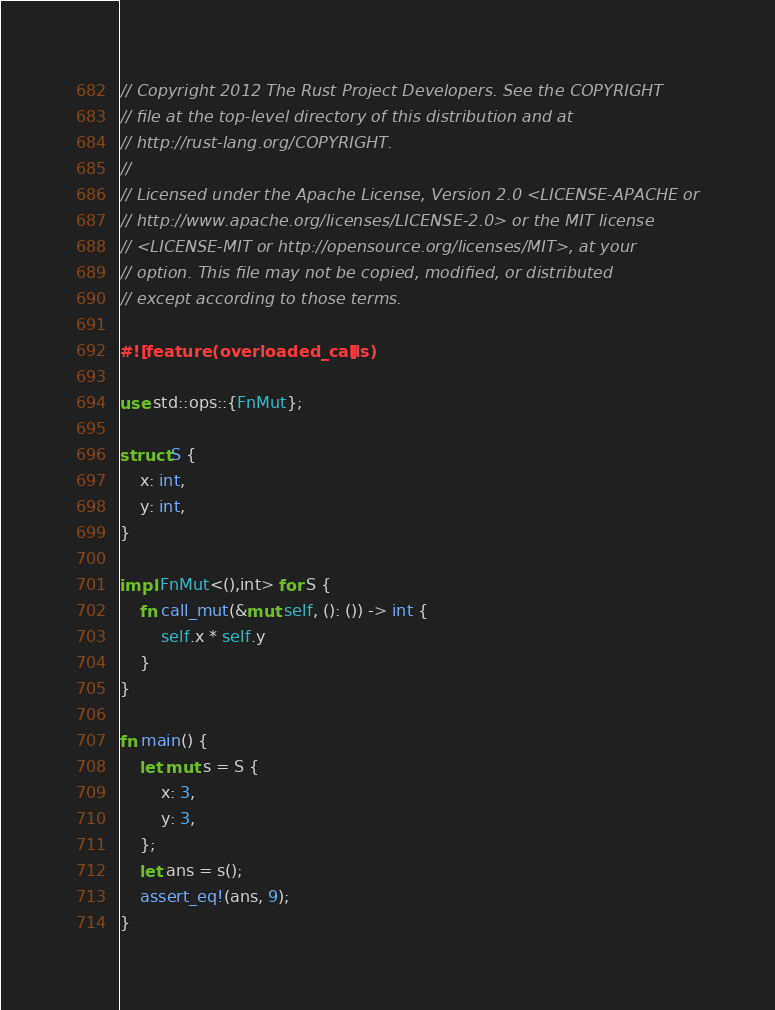<code> <loc_0><loc_0><loc_500><loc_500><_Rust_>// Copyright 2012 The Rust Project Developers. See the COPYRIGHT
// file at the top-level directory of this distribution and at
// http://rust-lang.org/COPYRIGHT.
//
// Licensed under the Apache License, Version 2.0 <LICENSE-APACHE or
// http://www.apache.org/licenses/LICENSE-2.0> or the MIT license
// <LICENSE-MIT or http://opensource.org/licenses/MIT>, at your
// option. This file may not be copied, modified, or distributed
// except according to those terms.

#![feature(overloaded_calls)]

use std::ops::{FnMut};

struct S {
    x: int,
    y: int,
}

impl FnMut<(),int> for S {
    fn call_mut(&mut self, (): ()) -> int {
        self.x * self.y
    }
}

fn main() {
    let mut s = S {
        x: 3,
        y: 3,
    };
    let ans = s();
    assert_eq!(ans, 9);
}


</code> 